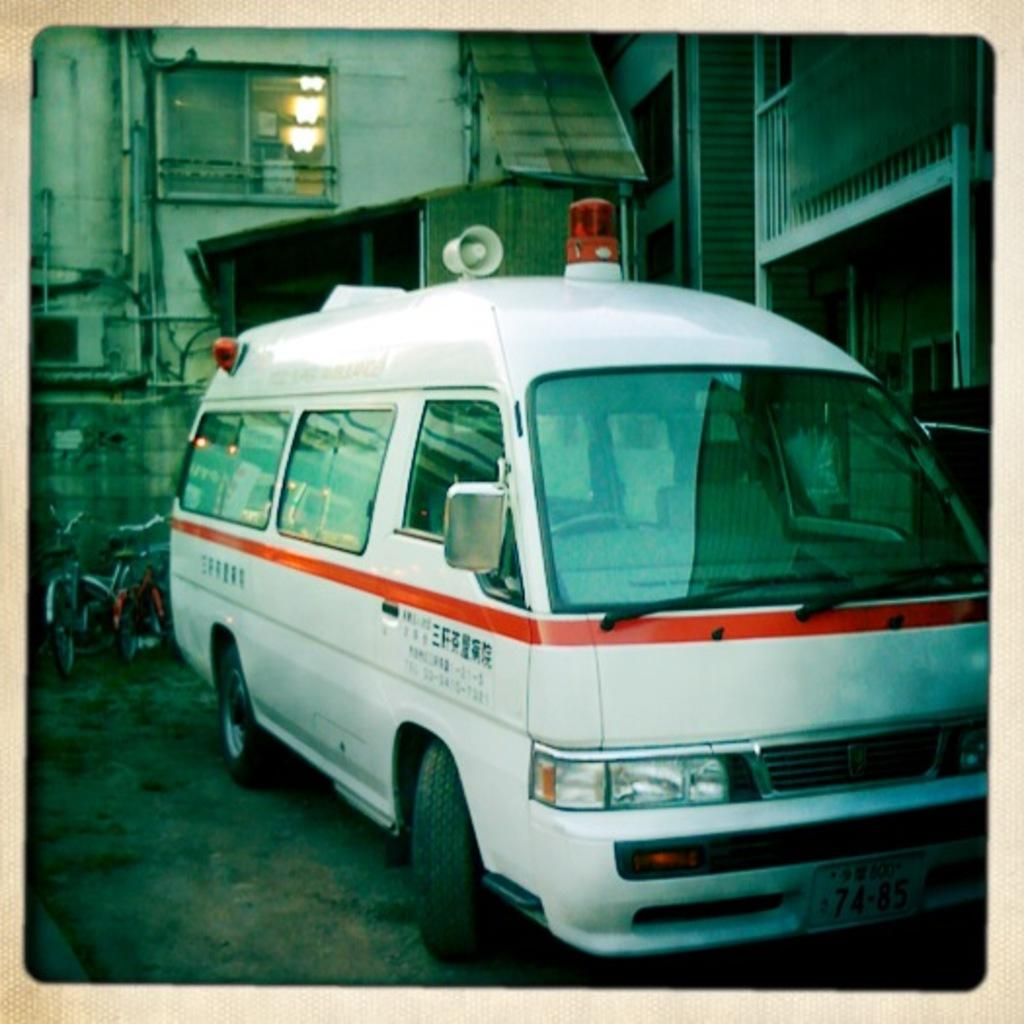What type of transportation is present in the image? There is a vehicle in the image. What other mode of transportation can be seen in the image? There are cycles in the image. What can be seen in the distance in the image? There are buildings in the background of the image. What type of dirt can be seen on the vehicle in the image? There is no dirt visible on the vehicle in the image. What emotion is the vehicle feeling in the image? Vehicles do not have emotions, so this question cannot be answered. 